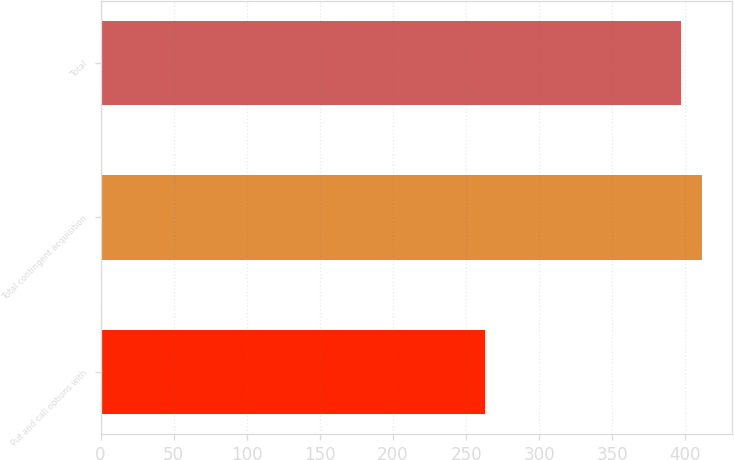Convert chart. <chart><loc_0><loc_0><loc_500><loc_500><bar_chart><fcel>Put and call options with<fcel>Total contingent acquisition<fcel>Total<nl><fcel>262.9<fcel>411.19<fcel>397.2<nl></chart> 